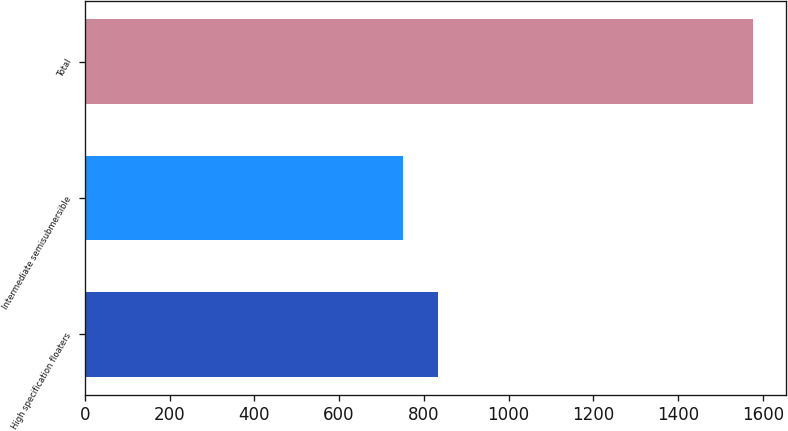Convert chart. <chart><loc_0><loc_0><loc_500><loc_500><bar_chart><fcel>High specification floaters<fcel>Intermediate semisubmersible<fcel>Total<nl><fcel>833.6<fcel>751<fcel>1577<nl></chart> 